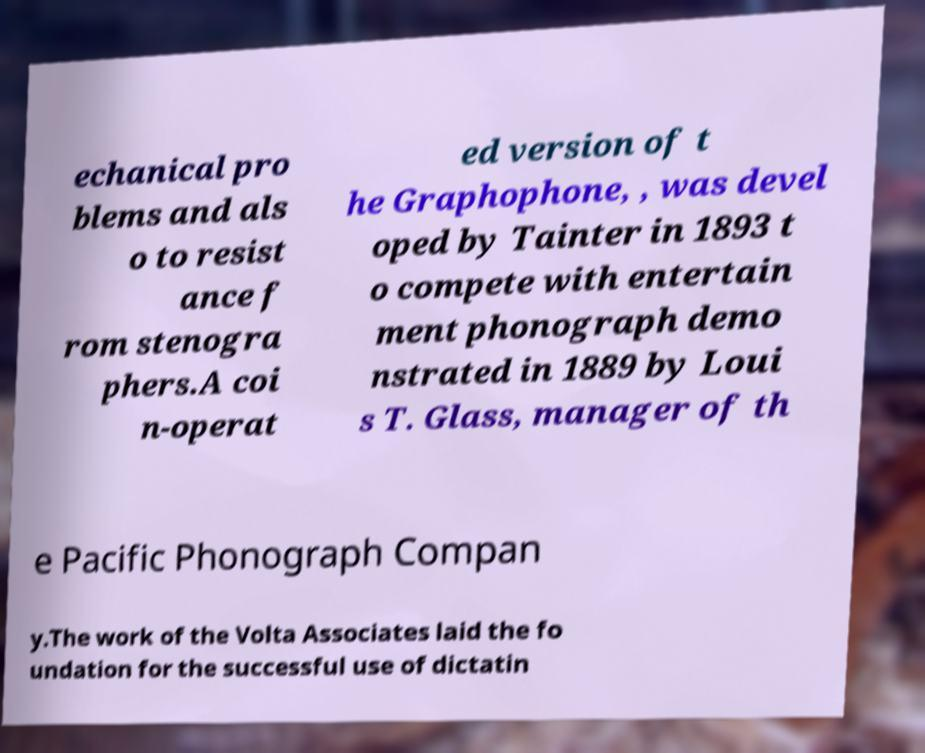There's text embedded in this image that I need extracted. Can you transcribe it verbatim? echanical pro blems and als o to resist ance f rom stenogra phers.A coi n-operat ed version of t he Graphophone, , was devel oped by Tainter in 1893 t o compete with entertain ment phonograph demo nstrated in 1889 by Loui s T. Glass, manager of th e Pacific Phonograph Compan y.The work of the Volta Associates laid the fo undation for the successful use of dictatin 